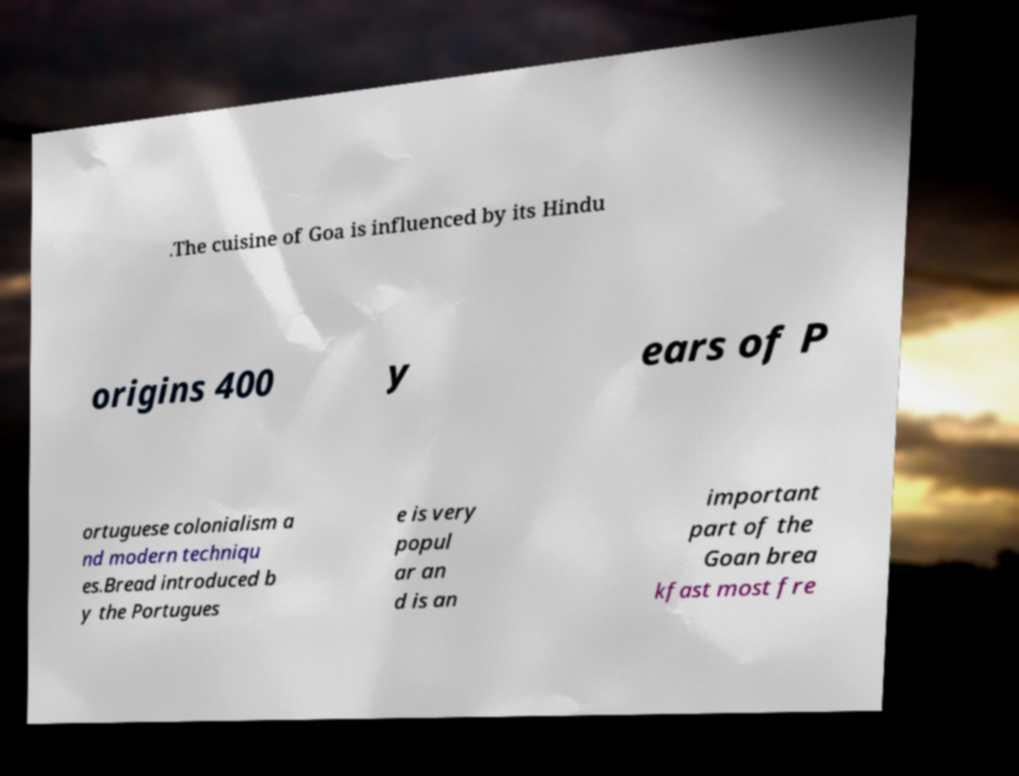I need the written content from this picture converted into text. Can you do that? .The cuisine of Goa is influenced by its Hindu origins 400 y ears of P ortuguese colonialism a nd modern techniqu es.Bread introduced b y the Portugues e is very popul ar an d is an important part of the Goan brea kfast most fre 